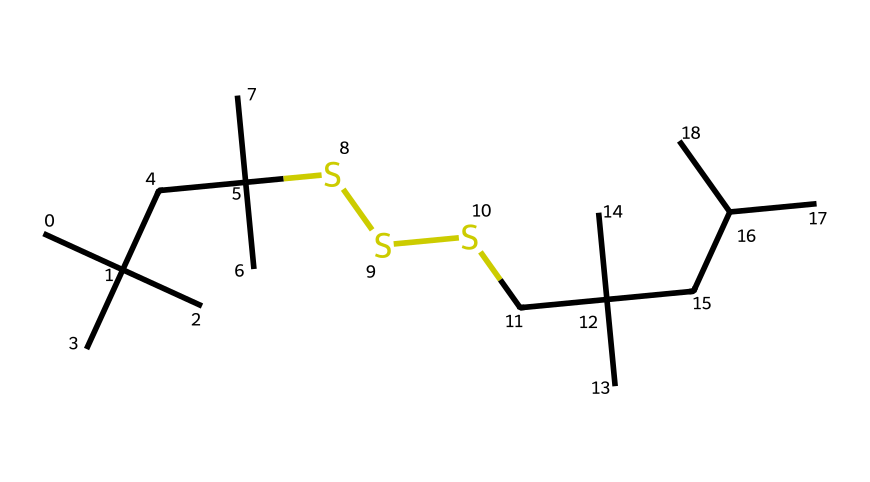What is the total number of sulfur atoms in this compound? The provided SMILES structure indicates the presence of three sulfur atoms, as represented by the letter 'S' appearing three times.
Answer: three How many carbon atoms are present in the molecular structure? By analyzing the SMILES representation, we count the number of carbon portions indicated by 'C', which totals fifteen carbon atoms.
Answer: fifteen What type of compound does this structure represent based on sulfur content? The presence of sulfur atoms connected to carbon chains indicates that this is an organosulfur compound, characterized by the functional groups formed by the sulfur-carbon connections.
Answer: organosulfur What is the branching characteristic of this organic compound? The SMILES notation shows multiple isopropyl groups (denoted by 'CC(C)(C)'), indicating that the compound has several branching points.
Answer: highly branched How many carbon chains (or segments) can be identified in the structure? The structure consists of multiple segments due to the branching and chain formation, and upon careful review, we can segment the carbon chains into five distinct branched segments.
Answer: five In terms of mechanical applications, what feature of organosulfur compounds enhances rubber properties? Organosulfur compounds are known to form cross-links (due to sulfur bonding), which improve elasticity and endurance of the vulcanized rubber used in mechanical applications.
Answer: cross-links 